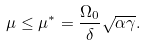Convert formula to latex. <formula><loc_0><loc_0><loc_500><loc_500>\mu \leq \mu ^ { \ast } = \frac { \Omega _ { 0 } } { \delta } \sqrt { \alpha \gamma } .</formula> 